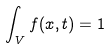<formula> <loc_0><loc_0><loc_500><loc_500>\int _ { V } f ( x , t ) = 1</formula> 